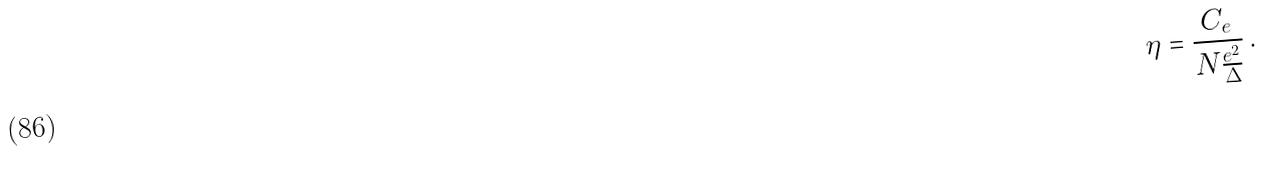Convert formula to latex. <formula><loc_0><loc_0><loc_500><loc_500>\eta = \frac { C _ { e } } { N \frac { e ^ { 2 } } \Delta } \, .</formula> 